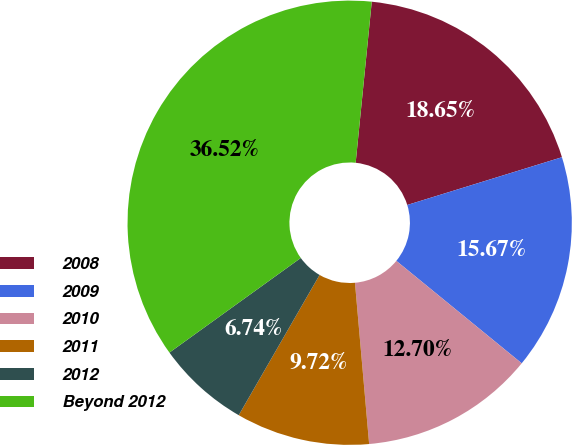<chart> <loc_0><loc_0><loc_500><loc_500><pie_chart><fcel>2008<fcel>2009<fcel>2010<fcel>2011<fcel>2012<fcel>Beyond 2012<nl><fcel>18.65%<fcel>15.67%<fcel>12.7%<fcel>9.72%<fcel>6.74%<fcel>36.52%<nl></chart> 